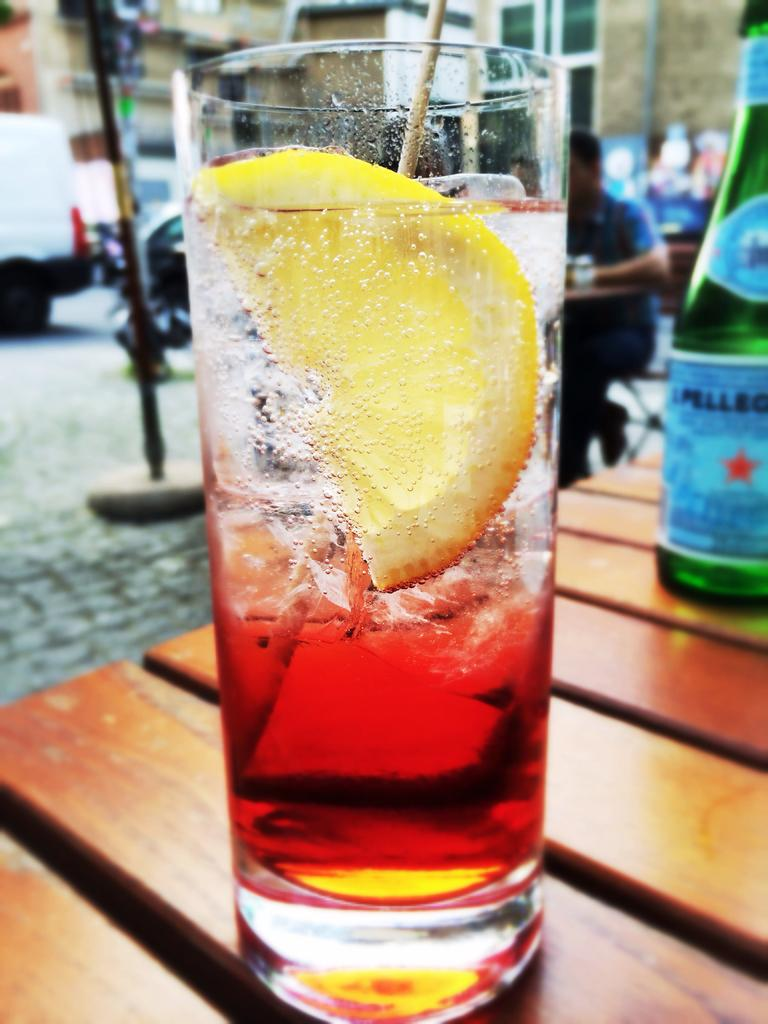What is in the glass that is visible in the image? There is a glass with liquid in the image. What fruit is present in the image? There is a lemon in the image. What object is on the table in the image? There is a bottle on the table in the image. What is the person in the image doing? There is a person sitting on a chair in the image. What type of corn is being used to make the person's memory better in the image? There is no corn present in the image, and the person's memory is not mentioned. 